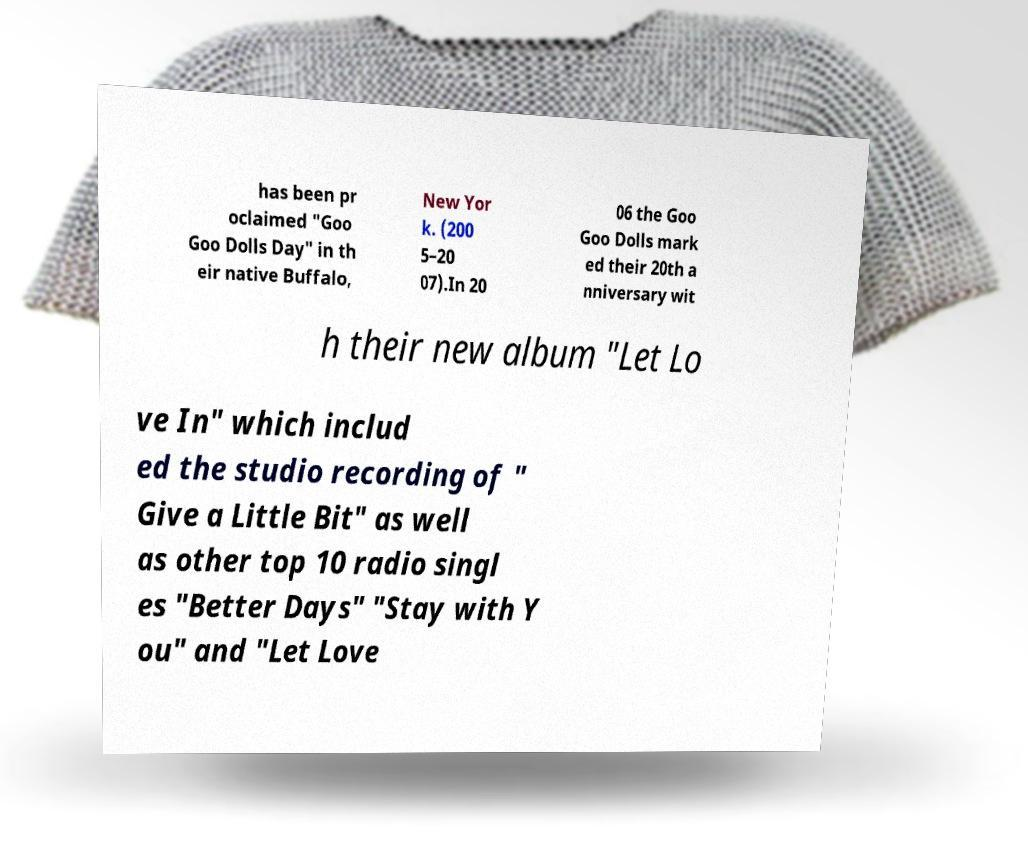There's text embedded in this image that I need extracted. Can you transcribe it verbatim? has been pr oclaimed "Goo Goo Dolls Day" in th eir native Buffalo, New Yor k. (200 5–20 07).In 20 06 the Goo Goo Dolls mark ed their 20th a nniversary wit h their new album "Let Lo ve In" which includ ed the studio recording of " Give a Little Bit" as well as other top 10 radio singl es "Better Days" "Stay with Y ou" and "Let Love 